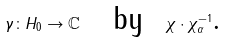<formula> <loc_0><loc_0><loc_500><loc_500>\gamma \colon H _ { 0 } \rightarrow \mathbb { C } \text { \ \ by \ } \chi \cdot \chi _ { \alpha } ^ { - 1 } \text {.}</formula> 